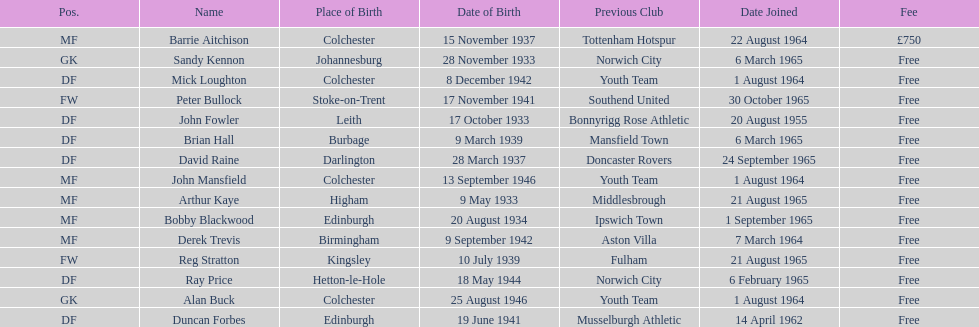Which player is the oldest? Arthur Kaye. 